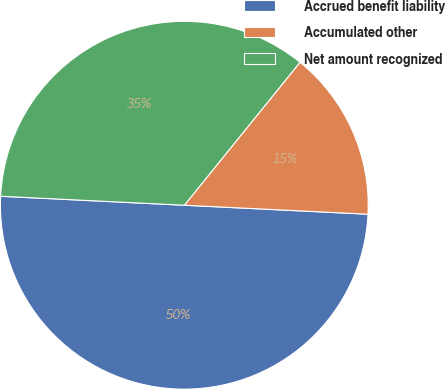<chart> <loc_0><loc_0><loc_500><loc_500><pie_chart><fcel>Accrued benefit liability<fcel>Accumulated other<fcel>Net amount recognized<nl><fcel>50.0%<fcel>14.95%<fcel>35.05%<nl></chart> 